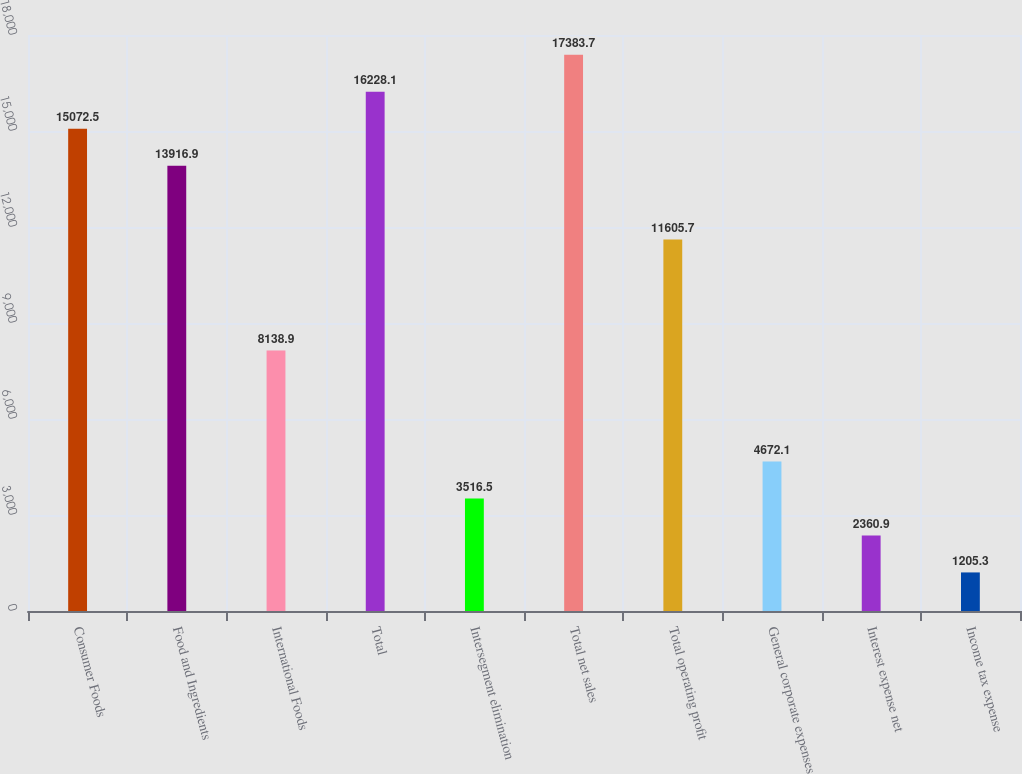<chart> <loc_0><loc_0><loc_500><loc_500><bar_chart><fcel>Consumer Foods<fcel>Food and Ingredients<fcel>International Foods<fcel>Total<fcel>Intersegment elimination<fcel>Total net sales<fcel>Total operating profit<fcel>General corporate expenses<fcel>Interest expense net<fcel>Income tax expense<nl><fcel>15072.5<fcel>13916.9<fcel>8138.9<fcel>16228.1<fcel>3516.5<fcel>17383.7<fcel>11605.7<fcel>4672.1<fcel>2360.9<fcel>1205.3<nl></chart> 